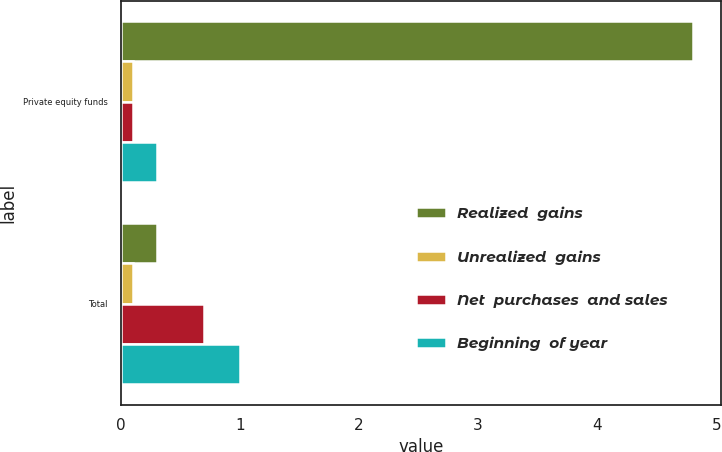<chart> <loc_0><loc_0><loc_500><loc_500><stacked_bar_chart><ecel><fcel>Private equity funds<fcel>Total<nl><fcel>Realized  gains<fcel>4.8<fcel>0.3<nl><fcel>Unrealized  gains<fcel>0.1<fcel>0.1<nl><fcel>Net  purchases  and sales<fcel>0.1<fcel>0.7<nl><fcel>Beginning  of year<fcel>0.3<fcel>1<nl></chart> 